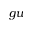<formula> <loc_0><loc_0><loc_500><loc_500>g u</formula> 